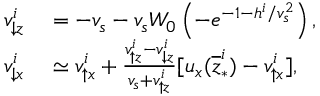<formula> <loc_0><loc_0><loc_500><loc_500>\begin{array} { r l } { v _ { \downarrow z } ^ { i } } & = - v _ { s } - v _ { s } W _ { 0 } \left ( - e ^ { - 1 - h ^ { i } / v _ { s } ^ { 2 } } \right ) , } \\ { v _ { \downarrow x } ^ { i } } & \simeq v _ { \uparrow x } ^ { i } + \frac { v _ { \uparrow z } ^ { i } - v _ { \downarrow z } ^ { i } } { v _ { s } + v _ { \uparrow z } ^ { i } } [ u _ { x } ( \overline { z } _ { \ast } ^ { i } ) - v _ { \uparrow x } ^ { i } ] , } \end{array}</formula> 